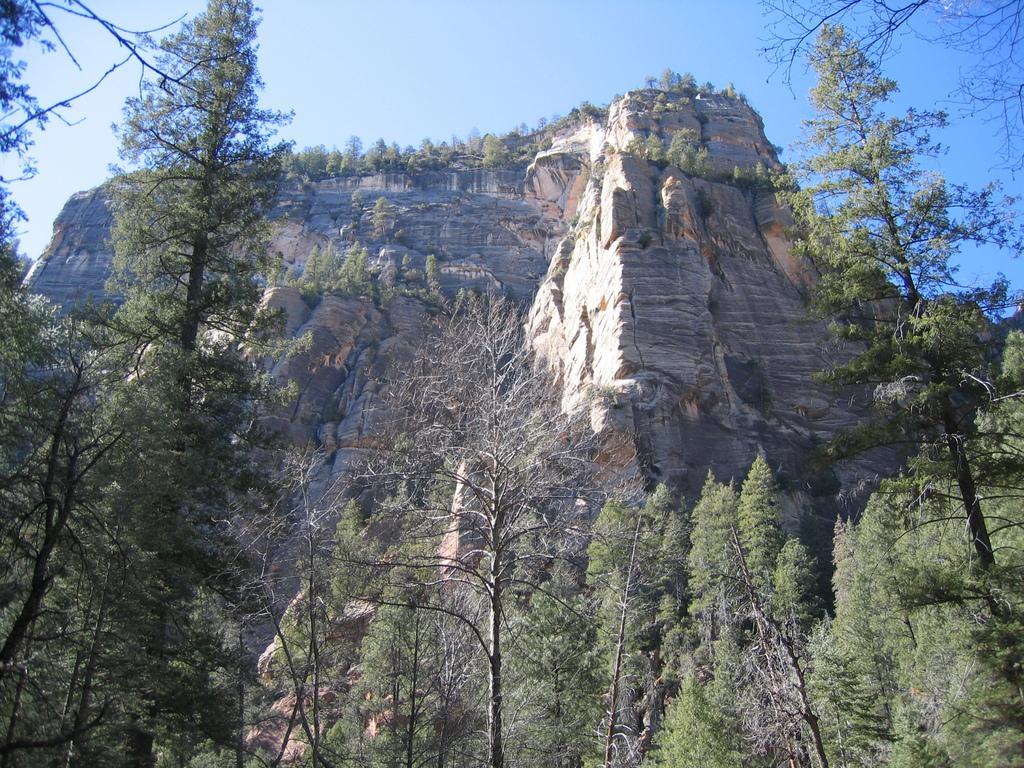How would you summarize this image in a sentence or two? In this picture we can see trees, mountains and in the background we can see the sky. 